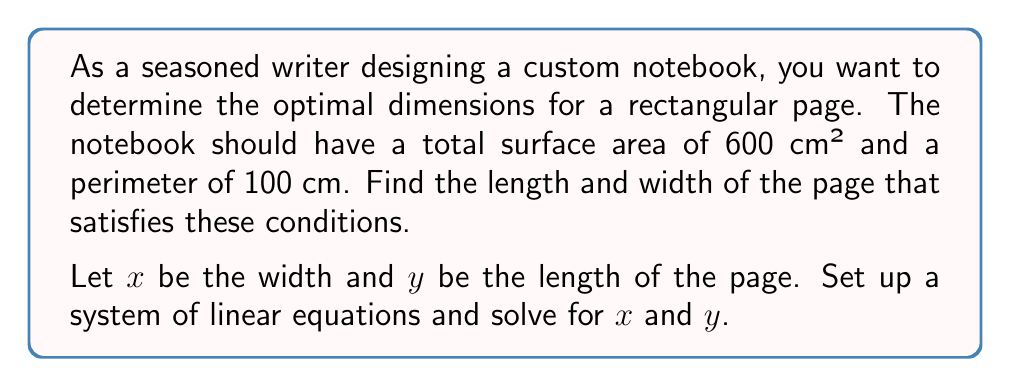Show me your answer to this math problem. Let's approach this step-by-step:

1) First, we need to set up our system of equations based on the given information:

   Area equation: $xy = 600$ (total surface area)
   Perimeter equation: $2x + 2y = 100$ (perimeter)

2) We can rewrite the perimeter equation to isolate $y$:
   
   $2x + 2y = 100$
   $2y = 100 - 2x$
   $y = 50 - x$

3) Now, substitute this expression for $y$ into the area equation:

   $x(50 - x) = 600$

4) Expand this equation:

   $50x - x² = 600$

5) Rearrange to standard quadratic form:

   $x² - 50x + 600 = 0$

6) This is a quadratic equation. We can solve it using the quadratic formula:
   
   $x = \frac{-b \pm \sqrt{b² - 4ac}}{2a}$

   Where $a = 1$, $b = -50$, and $c = 600$

7) Plugging in these values:

   $x = \frac{50 \pm \sqrt{2500 - 2400}}{2} = \frac{50 \pm \sqrt{100}}{2} = \frac{50 \pm 10}{2}$

8) This gives us two solutions:

   $x = 30$ or $x = 20$

9) We can find the corresponding $y$ values using $y = 50 - x$:

   When $x = 30$, $y = 20$
   When $x = 20$, $y = 30$

10) Both of these solutions satisfy our original equations. The dimensions can be 30 cm × 20 cm or 20 cm × 30 cm.
Answer: The optimal dimensions for the notebook page are either 30 cm × 20 cm or 20 cm × 30 cm. 